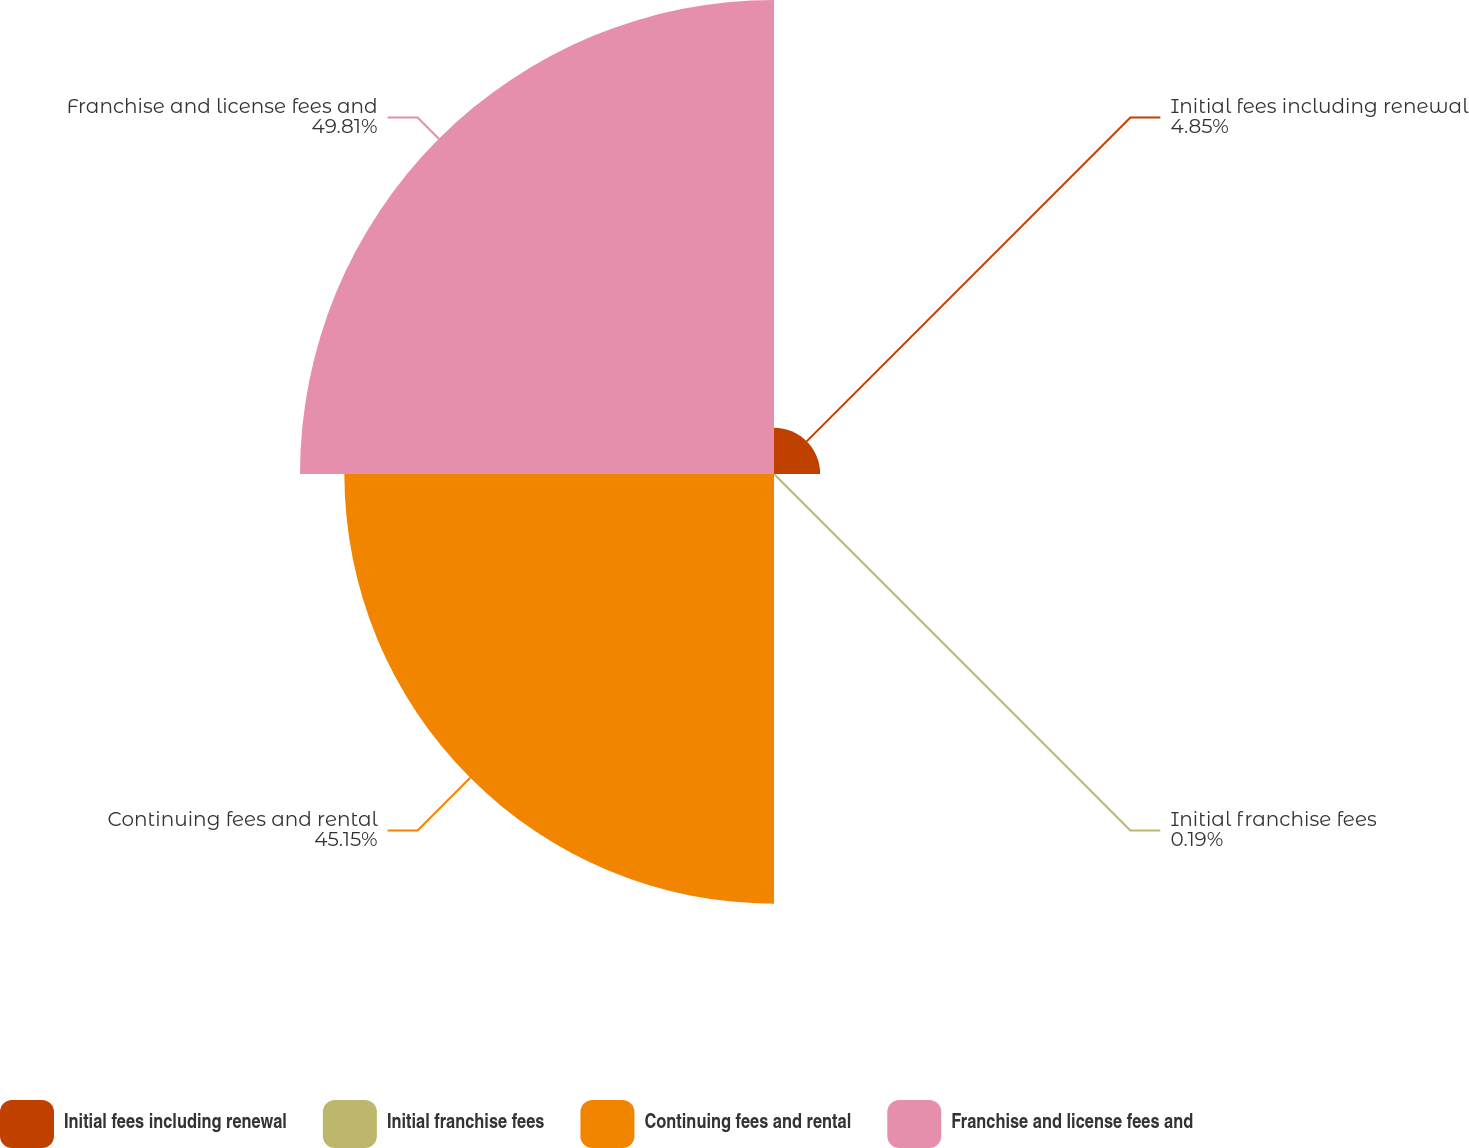Convert chart. <chart><loc_0><loc_0><loc_500><loc_500><pie_chart><fcel>Initial fees including renewal<fcel>Initial franchise fees<fcel>Continuing fees and rental<fcel>Franchise and license fees and<nl><fcel>4.85%<fcel>0.19%<fcel>45.15%<fcel>49.81%<nl></chart> 